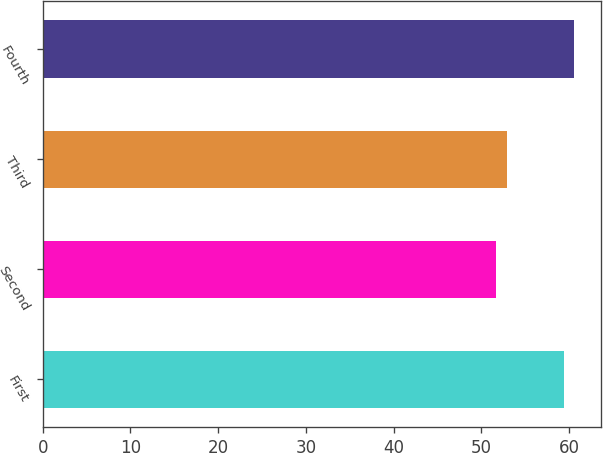Convert chart. <chart><loc_0><loc_0><loc_500><loc_500><bar_chart><fcel>First<fcel>Second<fcel>Third<fcel>Fourth<nl><fcel>59.42<fcel>51.67<fcel>52.91<fcel>60.57<nl></chart> 